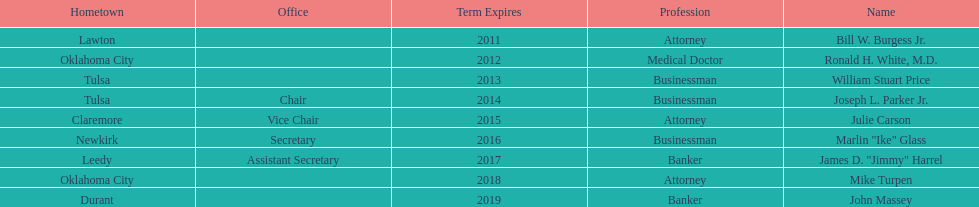How many members had businessman listed as their profession? 3. 